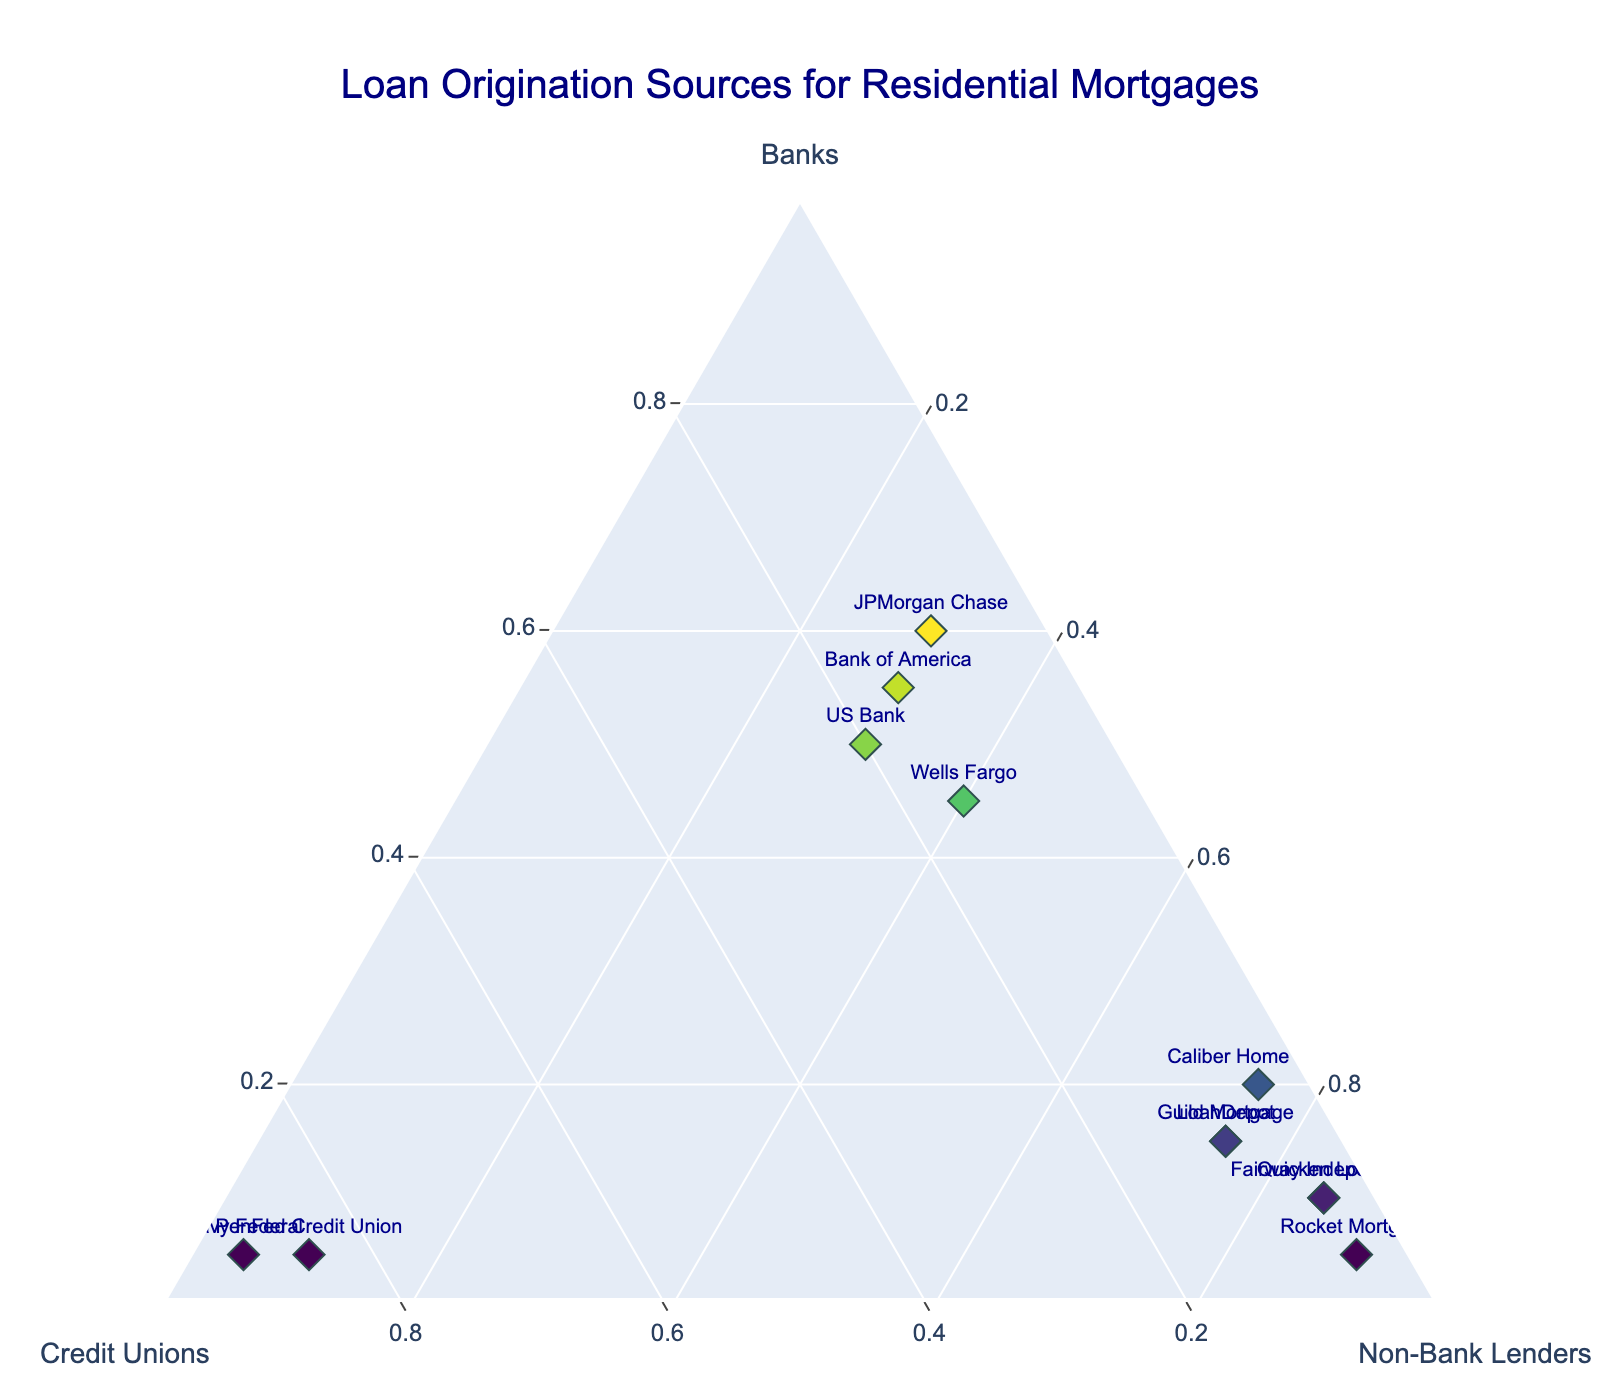What's the title of the figure? The title is generally placed at the top of the figure; in this case, it reads "Loan Origination Sources for Residential Mortgages".
Answer: Loan Origination Sources for Residential Mortgages Which entity originates the highest percentage of loans from credit unions? Among the entities represented, Navy Federal has the highest point on the Credit Unions axis, indicating a 90% origination from credit unions.
Answer: Navy Federal What is the proportion of loans originated by Bank of America across banks, credit unions, and non-bank lenders? Bank of America is positioned on the ternary plot such that its coordinates reflect its loan origination proportions: 55% Banks, 15% Credit Unions, and 30% Non-Bank Lenders.
Answer: 55% Banks, 15% Credit Unions, 30% Non-Bank Lenders Between Quicken Loans and Fairway Independent, which entity has a higher percentage of loans originated by non-bank lenders? Both entities are near the Non-Bank Lenders apex, but Quicken Loans is closer, showing it has a higher percentage (85%) compared to Fairway Independent (also 85%).
Answer: Quicken Loans What are the axis labels of the ternary plot? The axes of a ternary plot typically reflect the three components being compared. In this case, the labels are 'Banks', 'Credit Unions', and 'Non-Bank Lenders'.
Answer: Banks, Credit Unions, Non-Bank Lenders Which entity has a balanced distribution among all three loan origination sources? Looking at the plot, no entity is equidistant from each apex which would indicate a balanced distribution. Most entities lie closer to one or two apexes.
Answer: None What is the median percentage of loans originated by banks among all entities? To find the median, list all bank origination percentages: 45%, 10%, 05%, 60%, 05%, 55%, 15%, 05%, 20%, 10%, 50%, 15%; ordering these gives 05%, 05%, 05%, 10%, 10%, 15%, 15%, 20%, 45%, 50%, 55%, 60%; the median is the average of the 6th and 7th values: (15% + 15%)/2.
Answer: 15% Which entities have the same distribution between Banks and Non-Bank Lenders? On the plot, Caliber Home Loans and LoanDepot both have equal coordinates for Banks (20% for Caliber and 15% for LoanDepot) and Non-Bank Lenders (both 75%).
Answer: Caliber Home Loans, LoanDepot Which entity has the second highest percentage of loans originated by credit unions after Navy Federal? After Navy Federal (90%), PenFed Credit Union stands as the second highest in the Credit Unions category with 85%.
Answer: PenFed Credit Union What percentage of loans did JPMorgan Chase originate from non-bank lenders? By examining the plot and the positioning of JPMorgan Chase, it can be determined that 30% of their loans are originated from non-bank lenders.
Answer: 30% 